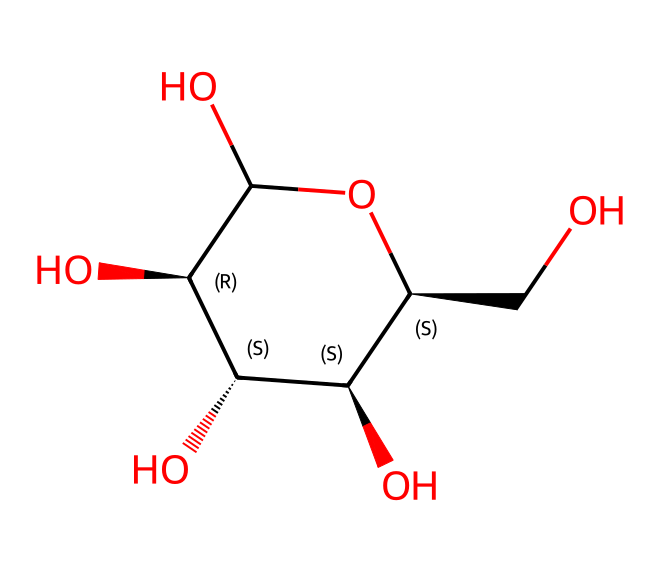What is the base molecule structure shown in the SMILES? The SMILES representation indicates a structure that corresponds to glucose, a simple sugar. The presence of hydroxyl groups and the cyclic form identifies it as a carbohydrate, specifically a sugar, linked to cotton fibers.
Answer: glucose How many carbon atoms are in this molecule? By interpreting the SMILES, we can count the carbon atoms present in the structure. The structure indicates a total of six carbon atoms (C).
Answer: six What type of functional groups are present in this structure? The visual structure contains multiple hydroxyl (-OH) groups, which are characteristic of alcohols. These functional groups are crucial for hydrogen bonding, contributing to the hydrophilic nature of cotton fibers.
Answer: hydroxyl What is the molecular formula derived from the SMILES? From analyzing the structure represented by the SMILES notation, we can derive the molecular formula which reflects the number of each type of atom present. The counts for carbon, hydrogen, and oxygen gives us C6H12O6.
Answer: C6H12O6 How does this molecule relate to the properties of natural cotton fibers? The molecule, being glucose, contributes to the cellulose production in cotton fibers. The arrangement of these glucose units (polymers) through glycosidic bonds creates strong structural fibers that are desirable in textiles for their durability and comfort.
Answer: cellulose What is the significance of the cyclic structure in terms of fiber strength? The cyclic structure allows for hydrogen bonding between adjacent molecules, which enhances stability and strength. This structural feature is crucial in providing cotton fibers with their tensile strength and flexibility, making them suitable for fabrics.
Answer: hydrogen bonding How does the number of hydroxyl groups influence the fiber’s absorption properties? The presence of multiple hydroxyl groups increases the hydrophilicity of the fibers, enhancing their ability to absorb moisture. This is important for comfort in textiles, as it allows the fabric to wick away moisture effectively.
Answer: increased absorption 